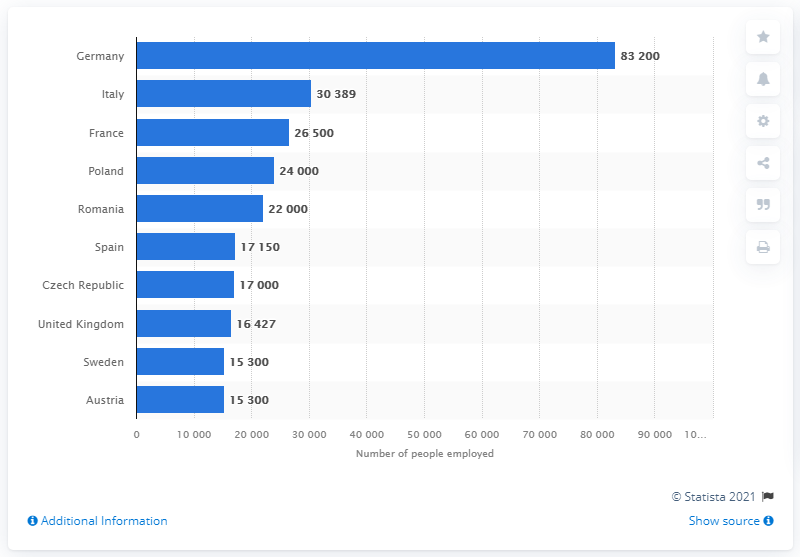Highlight a few significant elements in this photo. Germany is the largest employer in the European steel industry. 